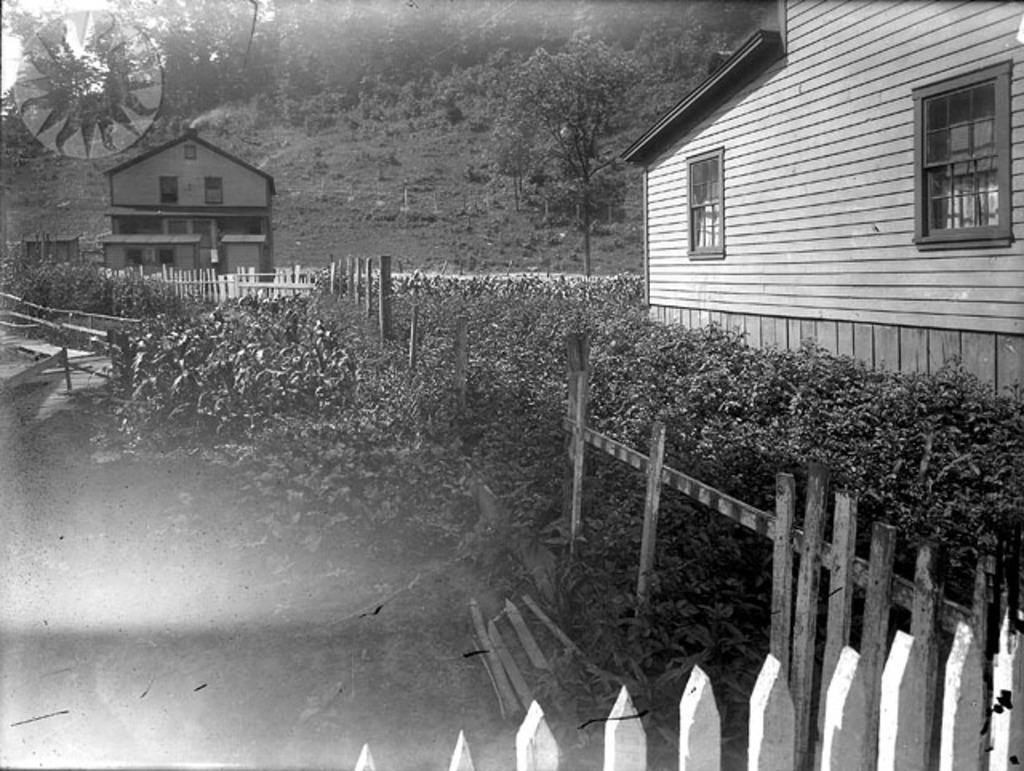In one or two sentences, can you explain what this image depicts? In this image I can see wooden fencing, bushes and two houses. I can also see number of trees in the background and on the top left side of this image I can see a watermark. I can also see this image is black and white in colour. 